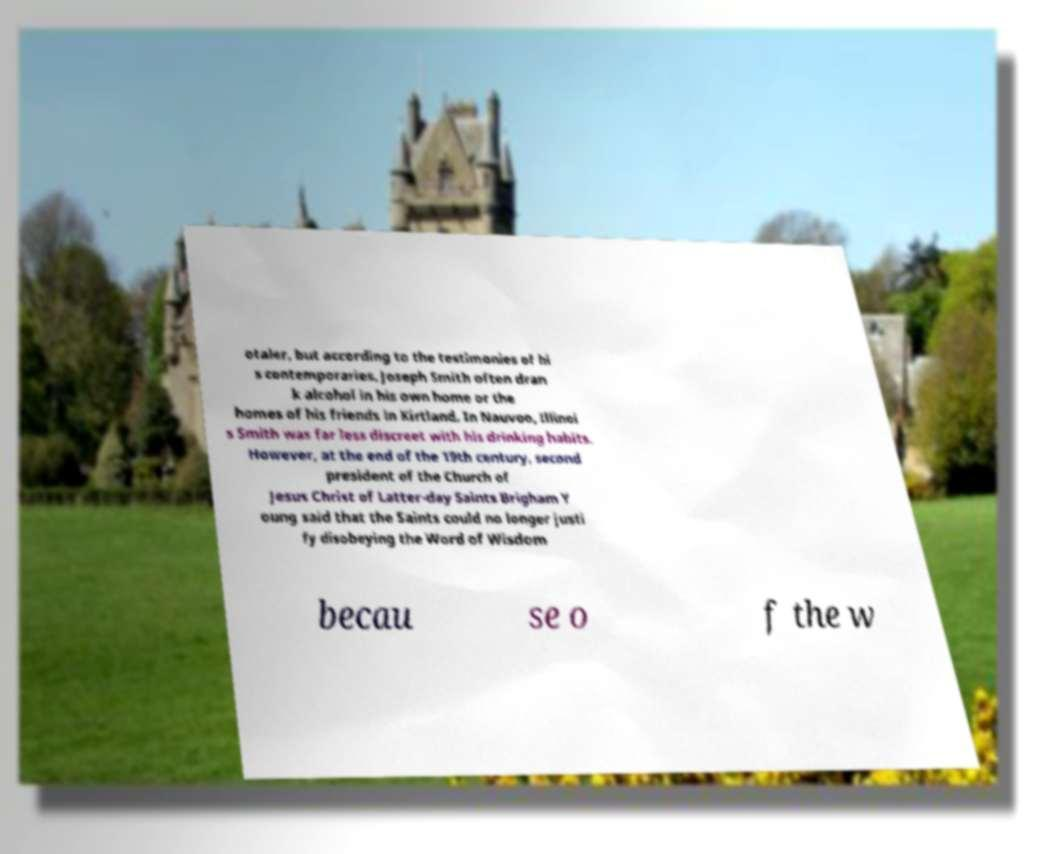I need the written content from this picture converted into text. Can you do that? otaler, but according to the testimonies of hi s contemporaries, Joseph Smith often dran k alcohol in his own home or the homes of his friends in Kirtland. In Nauvoo, Illinoi s Smith was far less discreet with his drinking habits. However, at the end of the 19th century, second president of the Church of Jesus Christ of Latter-day Saints Brigham Y oung said that the Saints could no longer justi fy disobeying the Word of Wisdom becau se o f the w 